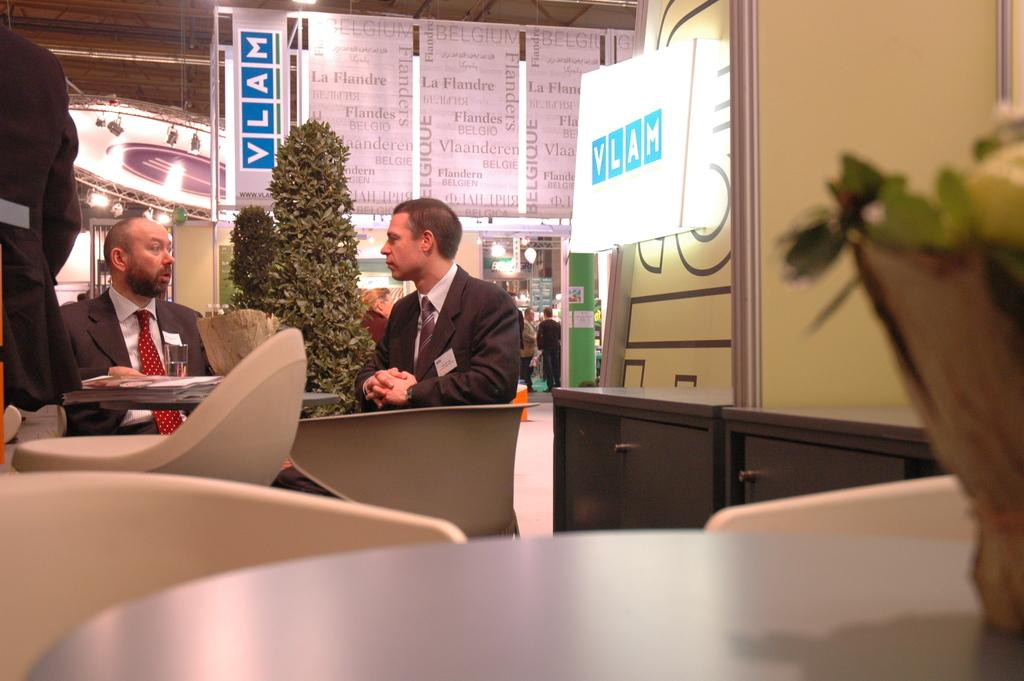How many persons are sitting in the image? There are two persons sitting on chairs in the image. What is the position of the third person in the image? There is a person standing in the image. What type of furniture is present in the image? There are chairs in the image. What can be found on the tables in the image? There are objects on tables in the image. Can you describe the background of the image? In the background, there are persons, lights visible, a plant, and boards. What type of haircut does the plant in the background have? The plant in the background does not have a haircut, as plants do not have hair. 